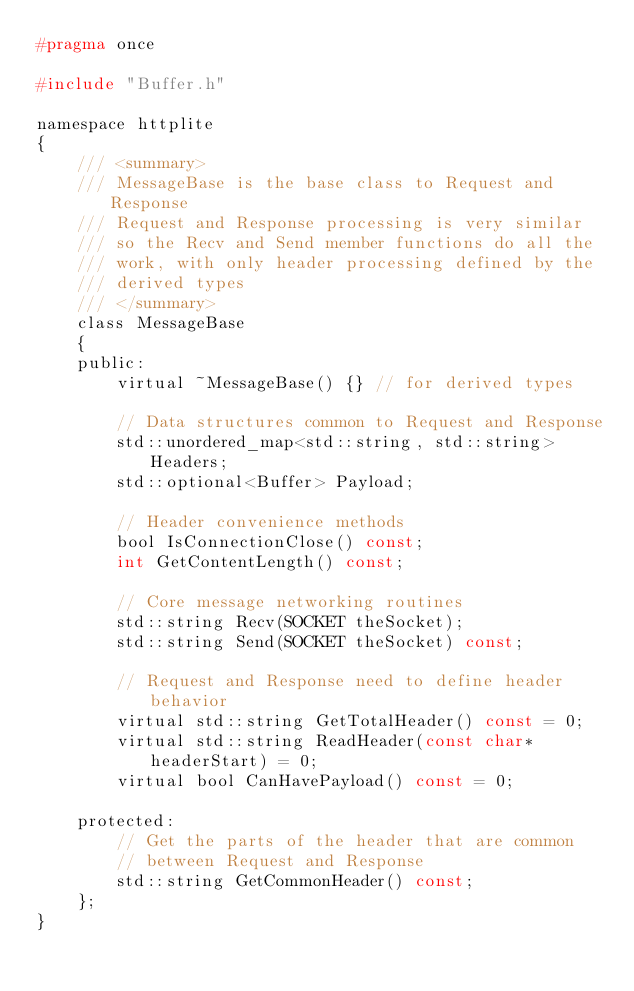<code> <loc_0><loc_0><loc_500><loc_500><_C_>#pragma once

#include "Buffer.h"

namespace httplite
{
	/// <summary>
	/// MessageBase is the base class to Request and Response
	/// Request and Response processing is very similar
	/// so the Recv and Send member functions do all the
	/// work, with only header processing defined by the
	/// derived types
	/// </summary>
	class MessageBase
	{
	public:
		virtual ~MessageBase() {} // for derived types

		// Data structures common to Request and Response
		std::unordered_map<std::string, std::string> Headers;
		std::optional<Buffer> Payload;

		// Header convenience methods
		bool IsConnectionClose() const;
		int GetContentLength() const;

		// Core message networking routines
		std::string Recv(SOCKET theSocket);
		std::string Send(SOCKET theSocket) const;

		// Request and Response need to define header behavior
		virtual std::string GetTotalHeader() const = 0;
		virtual std::string ReadHeader(const char* headerStart) = 0;
		virtual bool CanHavePayload() const = 0;

	protected:
		// Get the parts of the header that are common
		// between Request and Response
		std::string GetCommonHeader() const;
	};
}
</code> 